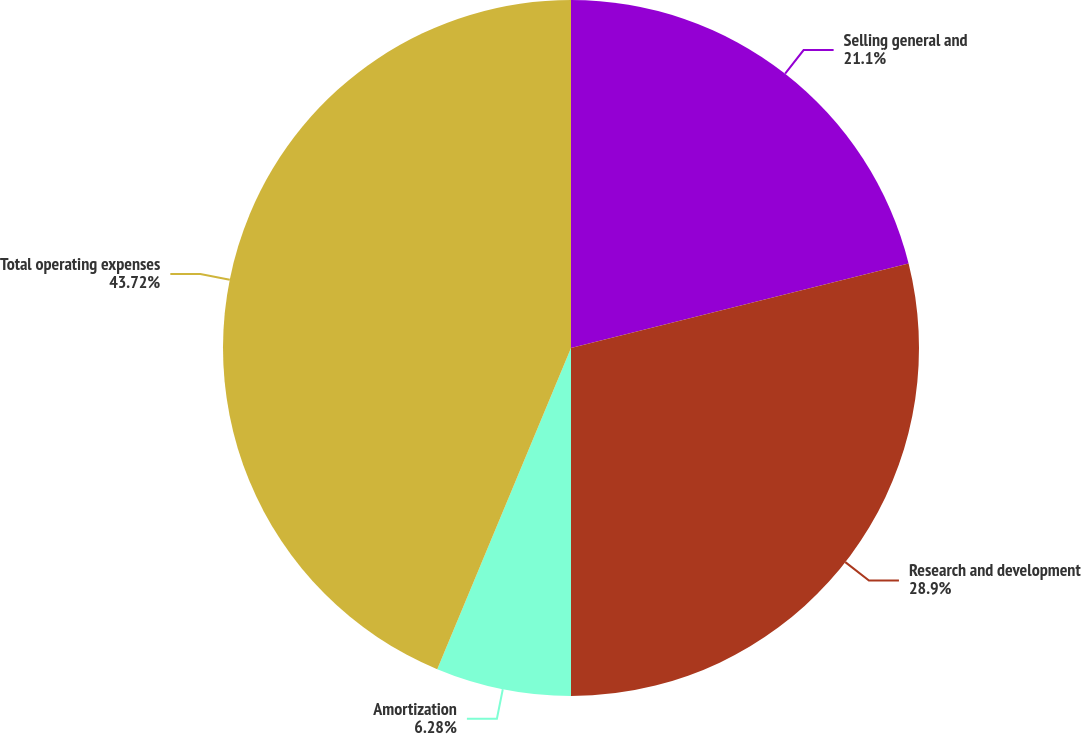Convert chart to OTSL. <chart><loc_0><loc_0><loc_500><loc_500><pie_chart><fcel>Selling general and<fcel>Research and development<fcel>Amortization<fcel>Total operating expenses<nl><fcel>21.1%<fcel>28.9%<fcel>6.28%<fcel>43.72%<nl></chart> 